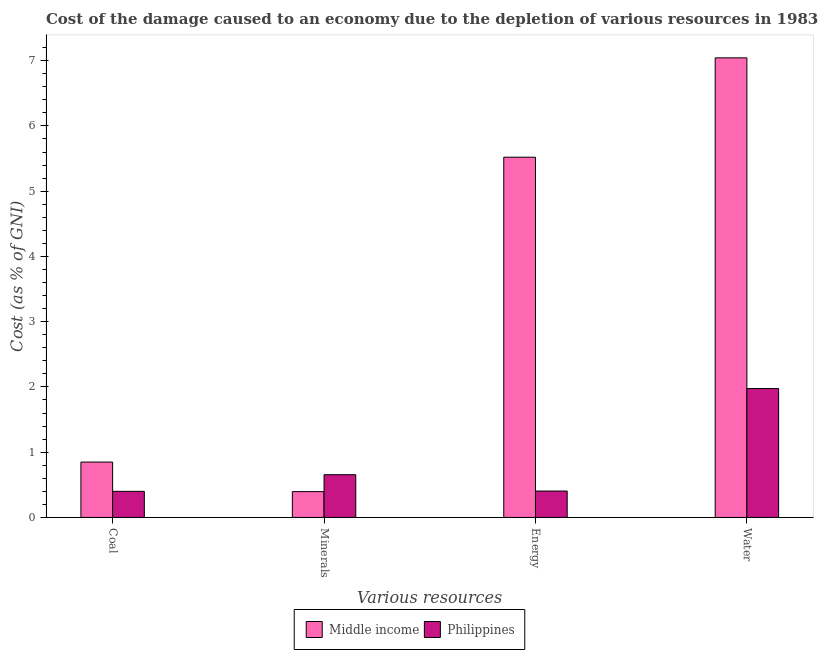How many groups of bars are there?
Your answer should be compact. 4. Are the number of bars per tick equal to the number of legend labels?
Provide a succinct answer. Yes. How many bars are there on the 2nd tick from the left?
Your response must be concise. 2. What is the label of the 3rd group of bars from the left?
Offer a terse response. Energy. What is the cost of damage due to depletion of water in Philippines?
Offer a very short reply. 1.98. Across all countries, what is the maximum cost of damage due to depletion of coal?
Your answer should be very brief. 0.85. Across all countries, what is the minimum cost of damage due to depletion of coal?
Make the answer very short. 0.4. In which country was the cost of damage due to depletion of energy maximum?
Provide a short and direct response. Middle income. What is the total cost of damage due to depletion of water in the graph?
Keep it short and to the point. 9.02. What is the difference between the cost of damage due to depletion of minerals in Middle income and that in Philippines?
Offer a very short reply. -0.26. What is the difference between the cost of damage due to depletion of coal in Philippines and the cost of damage due to depletion of energy in Middle income?
Offer a very short reply. -5.12. What is the average cost of damage due to depletion of minerals per country?
Your answer should be compact. 0.53. What is the difference between the cost of damage due to depletion of water and cost of damage due to depletion of energy in Middle income?
Offer a very short reply. 1.52. In how many countries, is the cost of damage due to depletion of minerals greater than 2.8 %?
Your response must be concise. 0. What is the ratio of the cost of damage due to depletion of water in Middle income to that in Philippines?
Offer a very short reply. 3.57. What is the difference between the highest and the second highest cost of damage due to depletion of water?
Make the answer very short. 5.07. What is the difference between the highest and the lowest cost of damage due to depletion of water?
Offer a terse response. 5.07. In how many countries, is the cost of damage due to depletion of energy greater than the average cost of damage due to depletion of energy taken over all countries?
Provide a succinct answer. 1. What does the 2nd bar from the left in Coal represents?
Your answer should be compact. Philippines. How many bars are there?
Give a very brief answer. 8. Are all the bars in the graph horizontal?
Make the answer very short. No. How many countries are there in the graph?
Provide a succinct answer. 2. What is the difference between two consecutive major ticks on the Y-axis?
Make the answer very short. 1. Are the values on the major ticks of Y-axis written in scientific E-notation?
Offer a terse response. No. Does the graph contain any zero values?
Provide a succinct answer. No. What is the title of the graph?
Provide a succinct answer. Cost of the damage caused to an economy due to the depletion of various resources in 1983 . What is the label or title of the X-axis?
Ensure brevity in your answer.  Various resources. What is the label or title of the Y-axis?
Your answer should be very brief. Cost (as % of GNI). What is the Cost (as % of GNI) in Middle income in Coal?
Your answer should be very brief. 0.85. What is the Cost (as % of GNI) of Philippines in Coal?
Ensure brevity in your answer.  0.4. What is the Cost (as % of GNI) in Middle income in Minerals?
Offer a very short reply. 0.4. What is the Cost (as % of GNI) of Philippines in Minerals?
Your answer should be very brief. 0.65. What is the Cost (as % of GNI) in Middle income in Energy?
Your answer should be very brief. 5.52. What is the Cost (as % of GNI) in Philippines in Energy?
Make the answer very short. 0.4. What is the Cost (as % of GNI) in Middle income in Water?
Offer a terse response. 7.04. What is the Cost (as % of GNI) in Philippines in Water?
Offer a terse response. 1.98. Across all Various resources, what is the maximum Cost (as % of GNI) in Middle income?
Your answer should be compact. 7.04. Across all Various resources, what is the maximum Cost (as % of GNI) of Philippines?
Your response must be concise. 1.98. Across all Various resources, what is the minimum Cost (as % of GNI) of Middle income?
Ensure brevity in your answer.  0.4. Across all Various resources, what is the minimum Cost (as % of GNI) in Philippines?
Ensure brevity in your answer.  0.4. What is the total Cost (as % of GNI) of Middle income in the graph?
Give a very brief answer. 13.81. What is the total Cost (as % of GNI) in Philippines in the graph?
Keep it short and to the point. 3.43. What is the difference between the Cost (as % of GNI) of Middle income in Coal and that in Minerals?
Ensure brevity in your answer.  0.45. What is the difference between the Cost (as % of GNI) of Philippines in Coal and that in Minerals?
Offer a very short reply. -0.26. What is the difference between the Cost (as % of GNI) in Middle income in Coal and that in Energy?
Give a very brief answer. -4.67. What is the difference between the Cost (as % of GNI) of Philippines in Coal and that in Energy?
Your answer should be very brief. -0. What is the difference between the Cost (as % of GNI) in Middle income in Coal and that in Water?
Keep it short and to the point. -6.19. What is the difference between the Cost (as % of GNI) in Philippines in Coal and that in Water?
Keep it short and to the point. -1.58. What is the difference between the Cost (as % of GNI) in Middle income in Minerals and that in Energy?
Your answer should be compact. -5.12. What is the difference between the Cost (as % of GNI) in Philippines in Minerals and that in Energy?
Your response must be concise. 0.25. What is the difference between the Cost (as % of GNI) of Middle income in Minerals and that in Water?
Keep it short and to the point. -6.65. What is the difference between the Cost (as % of GNI) of Philippines in Minerals and that in Water?
Ensure brevity in your answer.  -1.32. What is the difference between the Cost (as % of GNI) of Middle income in Energy and that in Water?
Provide a succinct answer. -1.52. What is the difference between the Cost (as % of GNI) in Philippines in Energy and that in Water?
Offer a very short reply. -1.57. What is the difference between the Cost (as % of GNI) of Middle income in Coal and the Cost (as % of GNI) of Philippines in Minerals?
Keep it short and to the point. 0.19. What is the difference between the Cost (as % of GNI) in Middle income in Coal and the Cost (as % of GNI) in Philippines in Energy?
Offer a terse response. 0.44. What is the difference between the Cost (as % of GNI) in Middle income in Coal and the Cost (as % of GNI) in Philippines in Water?
Offer a terse response. -1.13. What is the difference between the Cost (as % of GNI) in Middle income in Minerals and the Cost (as % of GNI) in Philippines in Energy?
Give a very brief answer. -0.01. What is the difference between the Cost (as % of GNI) of Middle income in Minerals and the Cost (as % of GNI) of Philippines in Water?
Ensure brevity in your answer.  -1.58. What is the difference between the Cost (as % of GNI) in Middle income in Energy and the Cost (as % of GNI) in Philippines in Water?
Provide a short and direct response. 3.54. What is the average Cost (as % of GNI) of Middle income per Various resources?
Give a very brief answer. 3.45. What is the average Cost (as % of GNI) in Philippines per Various resources?
Offer a terse response. 0.86. What is the difference between the Cost (as % of GNI) of Middle income and Cost (as % of GNI) of Philippines in Coal?
Offer a terse response. 0.45. What is the difference between the Cost (as % of GNI) of Middle income and Cost (as % of GNI) of Philippines in Minerals?
Keep it short and to the point. -0.26. What is the difference between the Cost (as % of GNI) of Middle income and Cost (as % of GNI) of Philippines in Energy?
Offer a terse response. 5.12. What is the difference between the Cost (as % of GNI) of Middle income and Cost (as % of GNI) of Philippines in Water?
Offer a very short reply. 5.07. What is the ratio of the Cost (as % of GNI) in Middle income in Coal to that in Minerals?
Ensure brevity in your answer.  2.14. What is the ratio of the Cost (as % of GNI) in Philippines in Coal to that in Minerals?
Provide a succinct answer. 0.61. What is the ratio of the Cost (as % of GNI) in Middle income in Coal to that in Energy?
Ensure brevity in your answer.  0.15. What is the ratio of the Cost (as % of GNI) in Philippines in Coal to that in Energy?
Your response must be concise. 0.99. What is the ratio of the Cost (as % of GNI) of Middle income in Coal to that in Water?
Ensure brevity in your answer.  0.12. What is the ratio of the Cost (as % of GNI) of Philippines in Coal to that in Water?
Your response must be concise. 0.2. What is the ratio of the Cost (as % of GNI) of Middle income in Minerals to that in Energy?
Your answer should be compact. 0.07. What is the ratio of the Cost (as % of GNI) of Philippines in Minerals to that in Energy?
Offer a terse response. 1.62. What is the ratio of the Cost (as % of GNI) of Middle income in Minerals to that in Water?
Your answer should be very brief. 0.06. What is the ratio of the Cost (as % of GNI) in Philippines in Minerals to that in Water?
Your response must be concise. 0.33. What is the ratio of the Cost (as % of GNI) in Middle income in Energy to that in Water?
Ensure brevity in your answer.  0.78. What is the ratio of the Cost (as % of GNI) in Philippines in Energy to that in Water?
Provide a succinct answer. 0.2. What is the difference between the highest and the second highest Cost (as % of GNI) in Middle income?
Offer a terse response. 1.52. What is the difference between the highest and the second highest Cost (as % of GNI) of Philippines?
Keep it short and to the point. 1.32. What is the difference between the highest and the lowest Cost (as % of GNI) of Middle income?
Give a very brief answer. 6.65. What is the difference between the highest and the lowest Cost (as % of GNI) in Philippines?
Ensure brevity in your answer.  1.58. 